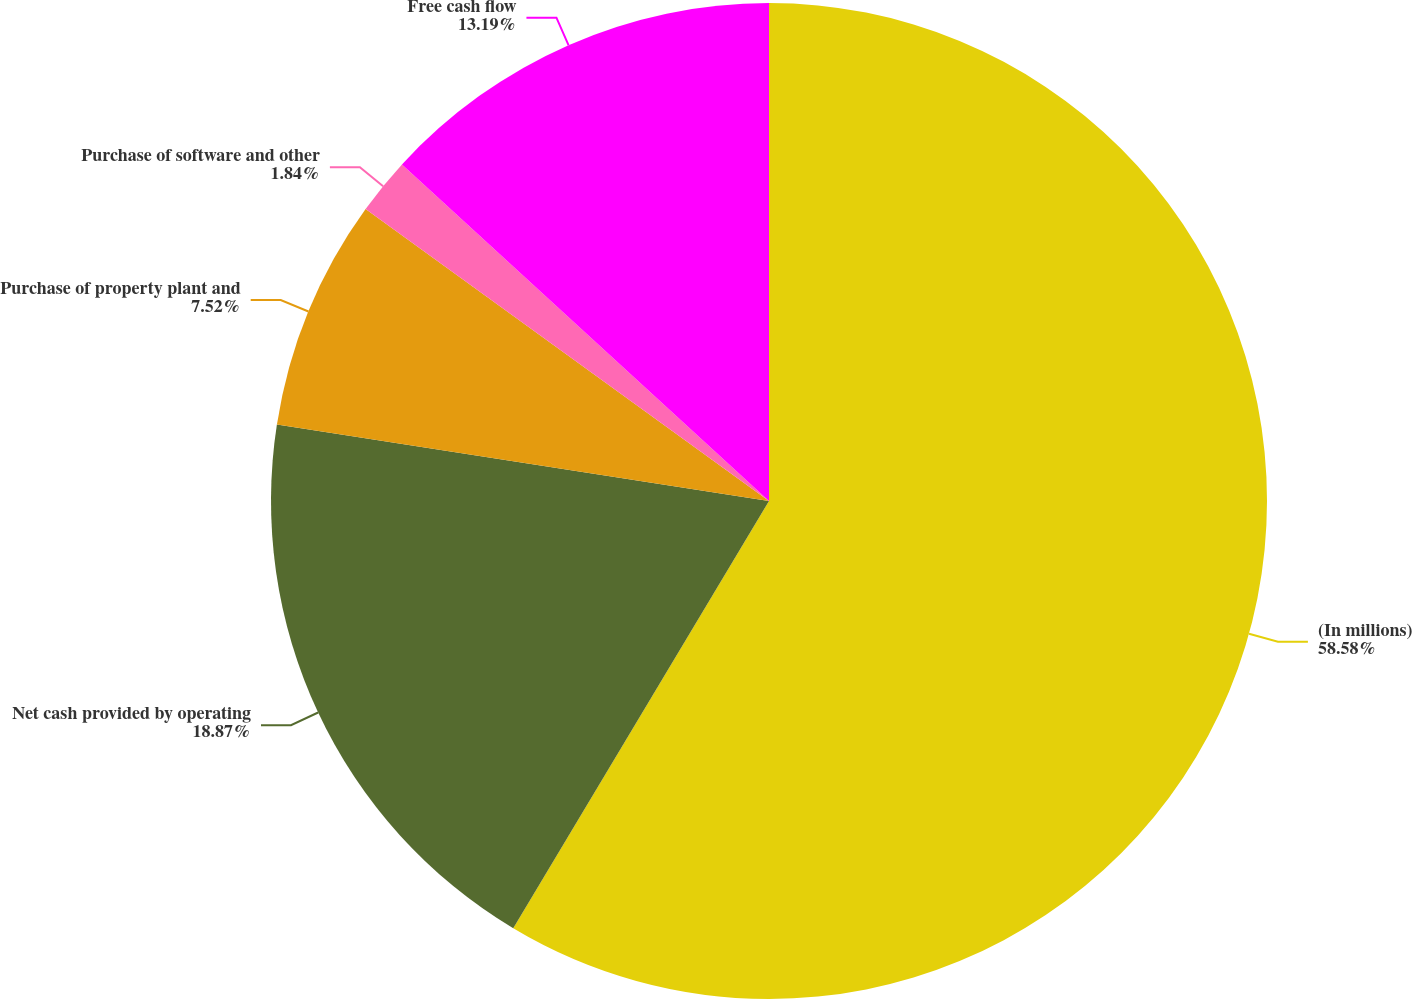Convert chart to OTSL. <chart><loc_0><loc_0><loc_500><loc_500><pie_chart><fcel>(In millions)<fcel>Net cash provided by operating<fcel>Purchase of property plant and<fcel>Purchase of software and other<fcel>Free cash flow<nl><fcel>58.59%<fcel>18.87%<fcel>7.52%<fcel>1.84%<fcel>13.19%<nl></chart> 